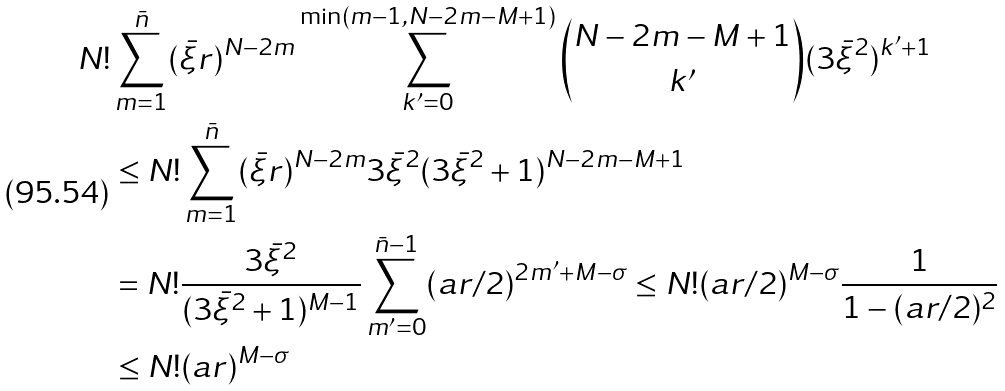<formula> <loc_0><loc_0><loc_500><loc_500>& N ! \sum _ { m = 1 } ^ { \bar { n } } ( \bar { \xi } r ) ^ { N - 2 m } \sum _ { k ^ { \prime } = 0 } ^ { \min ( m - 1 , N - 2 m - M + 1 ) } \binom { N - 2 m - M + 1 } { k ^ { \prime } } ( 3 \bar { \xi } ^ { 2 } ) ^ { k ^ { \prime } + 1 } \\ & \quad \leq N ! \sum _ { m = 1 } ^ { \bar { n } } ( \bar { \xi } r ) ^ { N - 2 m } 3 \bar { \xi } ^ { 2 } ( 3 \bar { \xi } ^ { 2 } + 1 ) ^ { N - 2 m - M + 1 } \\ & \quad = N ! \frac { 3 \bar { \xi } ^ { 2 } } { ( 3 \bar { \xi } ^ { 2 } + 1 ) ^ { M - 1 } } \sum _ { m ^ { \prime } = 0 } ^ { \bar { n } - 1 } ( a r / 2 ) ^ { 2 m ^ { \prime } + M - \sigma } \leq N ! ( a r / 2 ) ^ { M - \sigma } \frac { 1 } { 1 - ( a r / 2 ) ^ { 2 } } \\ & \quad \leq N ! ( a r ) ^ { M - \sigma }</formula> 